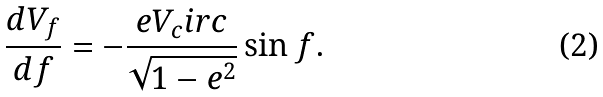Convert formula to latex. <formula><loc_0><loc_0><loc_500><loc_500>\frac { d V _ { f } } { d f } = - \frac { e V _ { c } i r c } { \sqrt { 1 - e ^ { 2 } } } \sin f .</formula> 